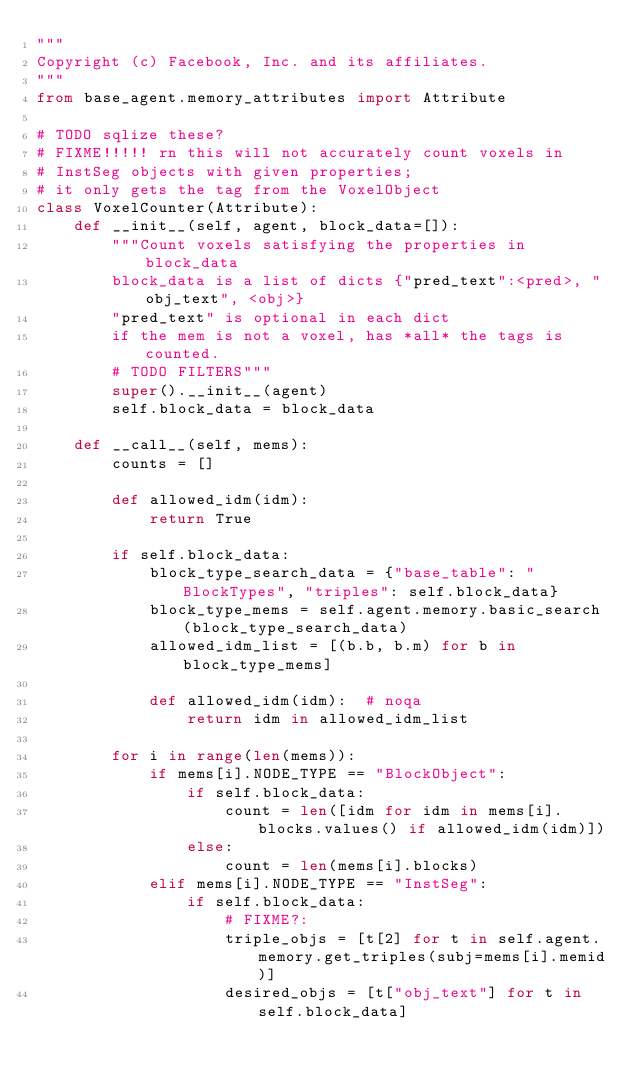Convert code to text. <code><loc_0><loc_0><loc_500><loc_500><_Python_>"""
Copyright (c) Facebook, Inc. and its affiliates.
"""
from base_agent.memory_attributes import Attribute

# TODO sqlize these?
# FIXME!!!!! rn this will not accurately count voxels in
# InstSeg objects with given properties;
# it only gets the tag from the VoxelObject
class VoxelCounter(Attribute):
    def __init__(self, agent, block_data=[]):
        """Count voxels satisfying the properties in block_data
        block_data is a list of dicts {"pred_text":<pred>, "obj_text", <obj>}
        "pred_text" is optional in each dict
        if the mem is not a voxel, has *all* the tags is counted.
        # TODO FILTERS"""
        super().__init__(agent)
        self.block_data = block_data

    def __call__(self, mems):
        counts = []

        def allowed_idm(idm):
            return True

        if self.block_data:
            block_type_search_data = {"base_table": "BlockTypes", "triples": self.block_data}
            block_type_mems = self.agent.memory.basic_search(block_type_search_data)
            allowed_idm_list = [(b.b, b.m) for b in block_type_mems]

            def allowed_idm(idm):  # noqa
                return idm in allowed_idm_list

        for i in range(len(mems)):
            if mems[i].NODE_TYPE == "BlockObject":
                if self.block_data:
                    count = len([idm for idm in mems[i].blocks.values() if allowed_idm(idm)])
                else:
                    count = len(mems[i].blocks)
            elif mems[i].NODE_TYPE == "InstSeg":
                if self.block_data:
                    # FIXME?:
                    triple_objs = [t[2] for t in self.agent.memory.get_triples(subj=mems[i].memid)]
                    desired_objs = [t["obj_text"] for t in self.block_data]</code> 